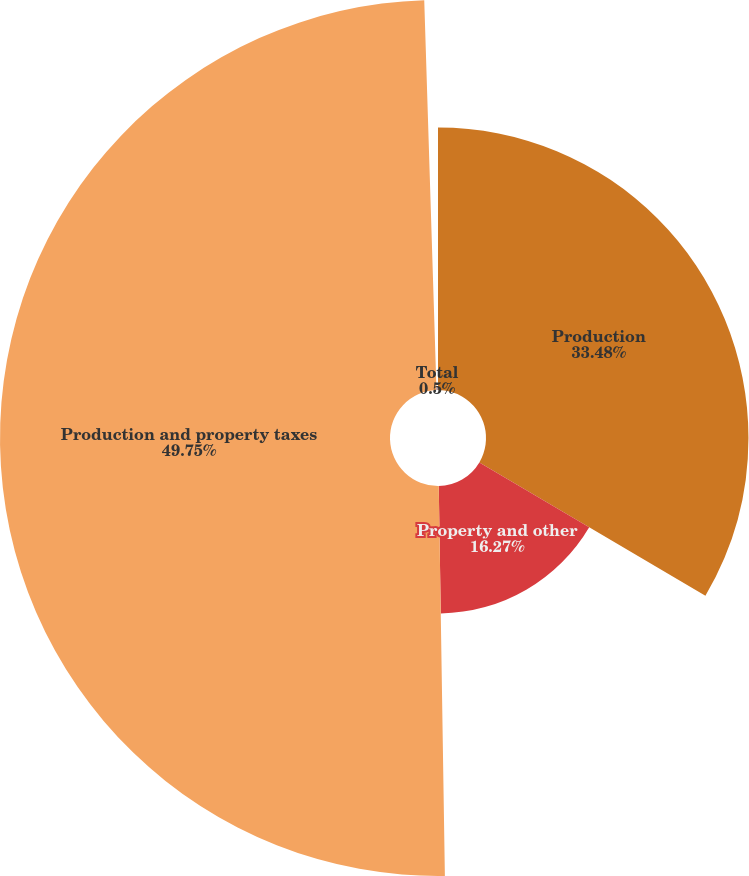Convert chart to OTSL. <chart><loc_0><loc_0><loc_500><loc_500><pie_chart><fcel>Production<fcel>Property and other<fcel>Production and property taxes<fcel>Total<nl><fcel>33.48%<fcel>16.27%<fcel>49.75%<fcel>0.5%<nl></chart> 